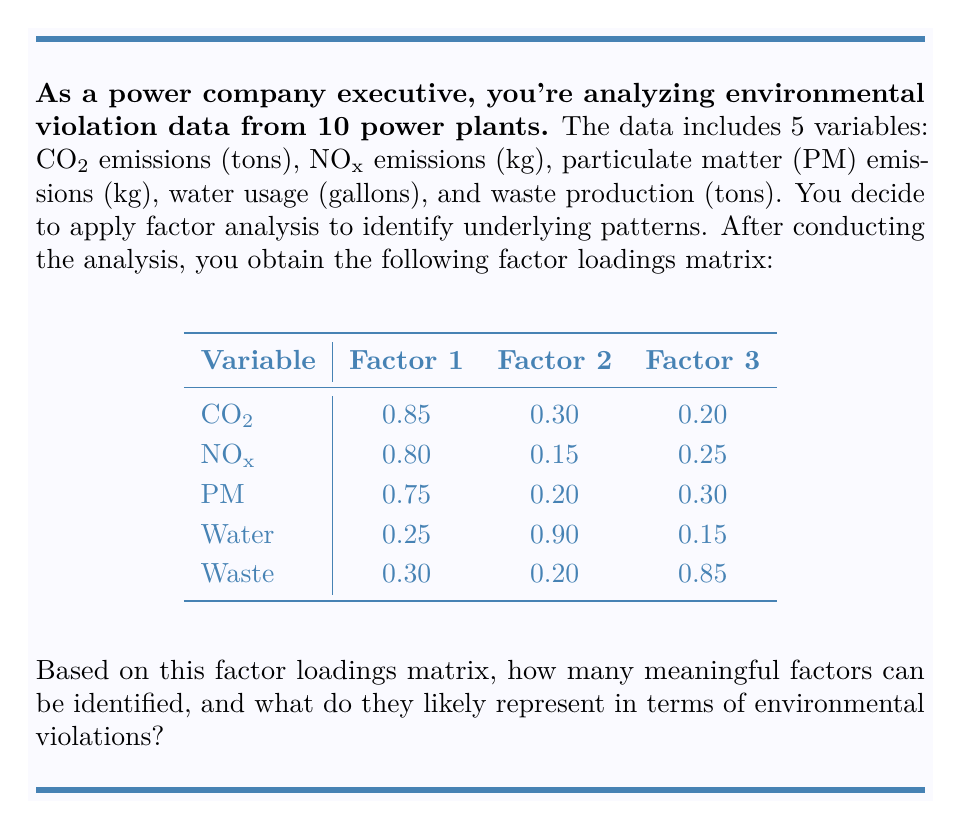Solve this math problem. To interpret the factor analysis results and determine the number of meaningful factors, we'll follow these steps:

1. Examine the factor loadings:
   - Factor loadings > 0.7 are considered high and indicate a strong relationship between the variable and the factor.
   - Factor loadings < 0.3 are considered low and indicate a weak relationship.

2. Identify variables with high loadings on each factor:
   Factor 1: CO2 (0.85), NOx (0.80), PM (0.75)
   Factor 2: Water (0.90)
   Factor 3: Waste (0.85)

3. Interpret the factors based on the variables they represent:
   Factor 1: High loadings on CO2, NOx, and PM suggest this factor represents air pollution.
   Factor 2: High loading on water usage suggests this factor represents water consumption.
   Factor 3: High loading on waste production suggests this factor represents solid waste generation.

4. Determine the number of meaningful factors:
   All three factors have at least one variable with a high loading (>0.7), so all three factors can be considered meaningful.

5. Relate factors to environmental violations:
   Factor 1 (Air Pollution): Violations related to excessive air emissions.
   Factor 2 (Water Consumption): Violations related to excessive water usage or improper water management.
   Factor 3 (Solid Waste): Violations related to improper waste disposal or excessive waste generation.

Therefore, the factor analysis reveals three meaningful factors that likely represent different types of environmental violations: air pollution, water consumption, and solid waste management.
Answer: 3 factors: air pollution, water consumption, and solid waste management 